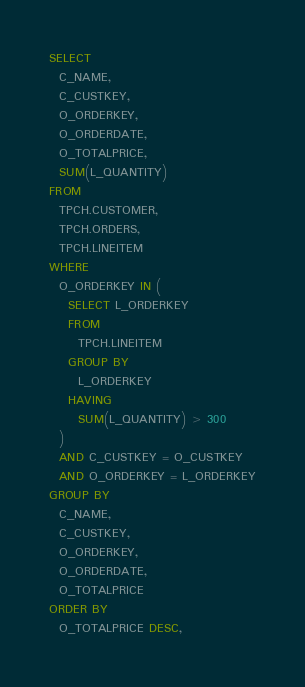<code> <loc_0><loc_0><loc_500><loc_500><_SQL_>SELECT
  C_NAME,
  C_CUSTKEY,
  O_ORDERKEY,
  O_ORDERDATE,
  O_TOTALPRICE,
  SUM(L_QUANTITY)
FROM
  TPCH.CUSTOMER,
  TPCH.ORDERS,
  TPCH.LINEITEM
WHERE
  O_ORDERKEY IN (
    SELECT L_ORDERKEY
    FROM
      TPCH.LINEITEM
    GROUP BY
      L_ORDERKEY
    HAVING
      SUM(L_QUANTITY) > 300
  )
  AND C_CUSTKEY = O_CUSTKEY
  AND O_ORDERKEY = L_ORDERKEY
GROUP BY
  C_NAME,
  C_CUSTKEY,
  O_ORDERKEY,
  O_ORDERDATE,
  O_TOTALPRICE
ORDER BY
  O_TOTALPRICE DESC,</code> 